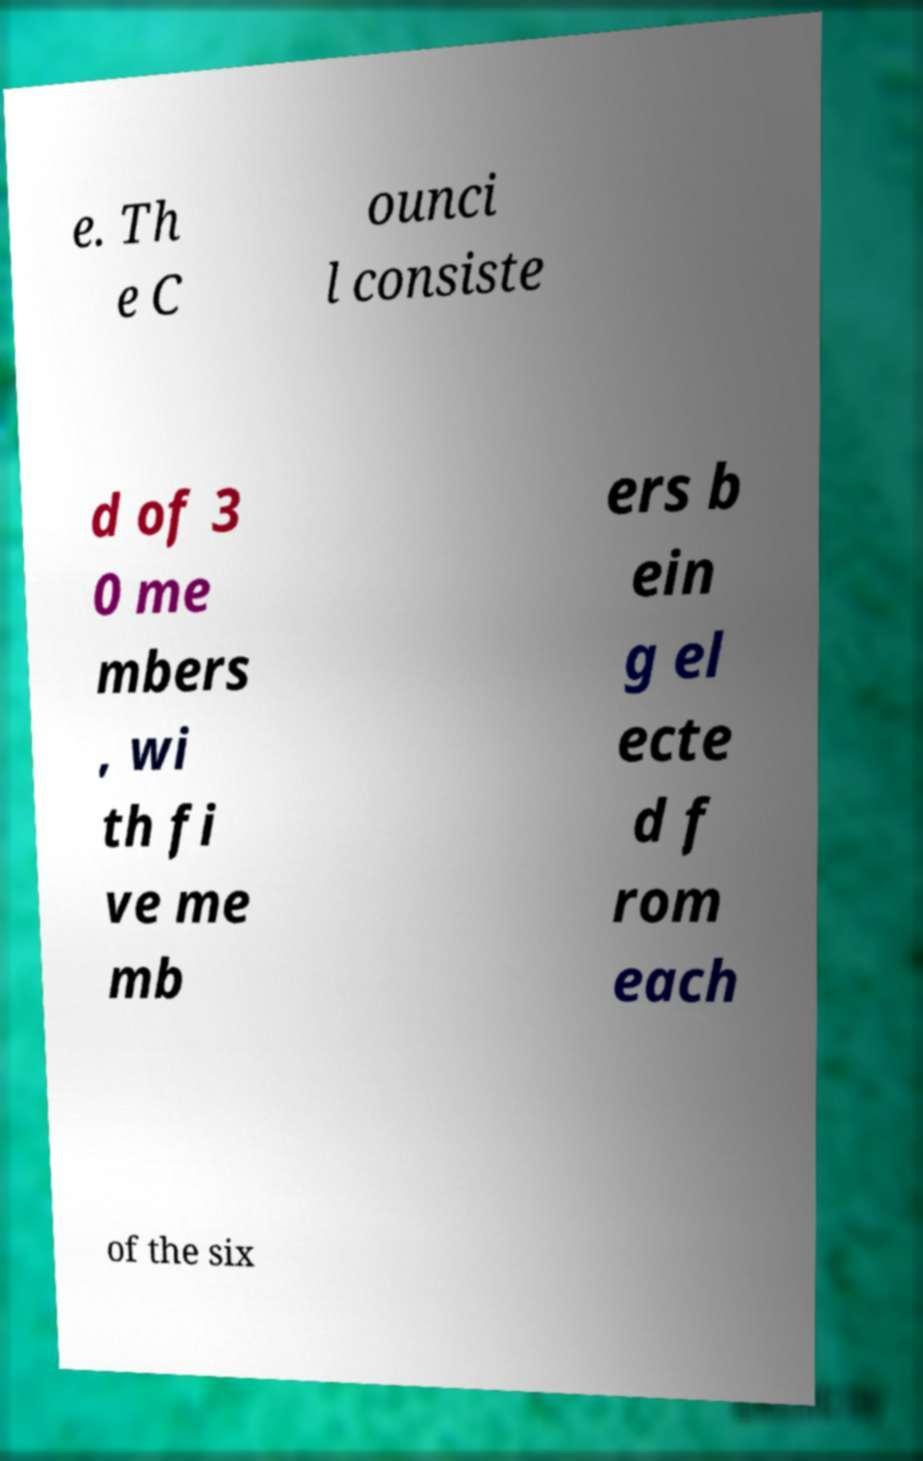Could you extract and type out the text from this image? e. Th e C ounci l consiste d of 3 0 me mbers , wi th fi ve me mb ers b ein g el ecte d f rom each of the six 